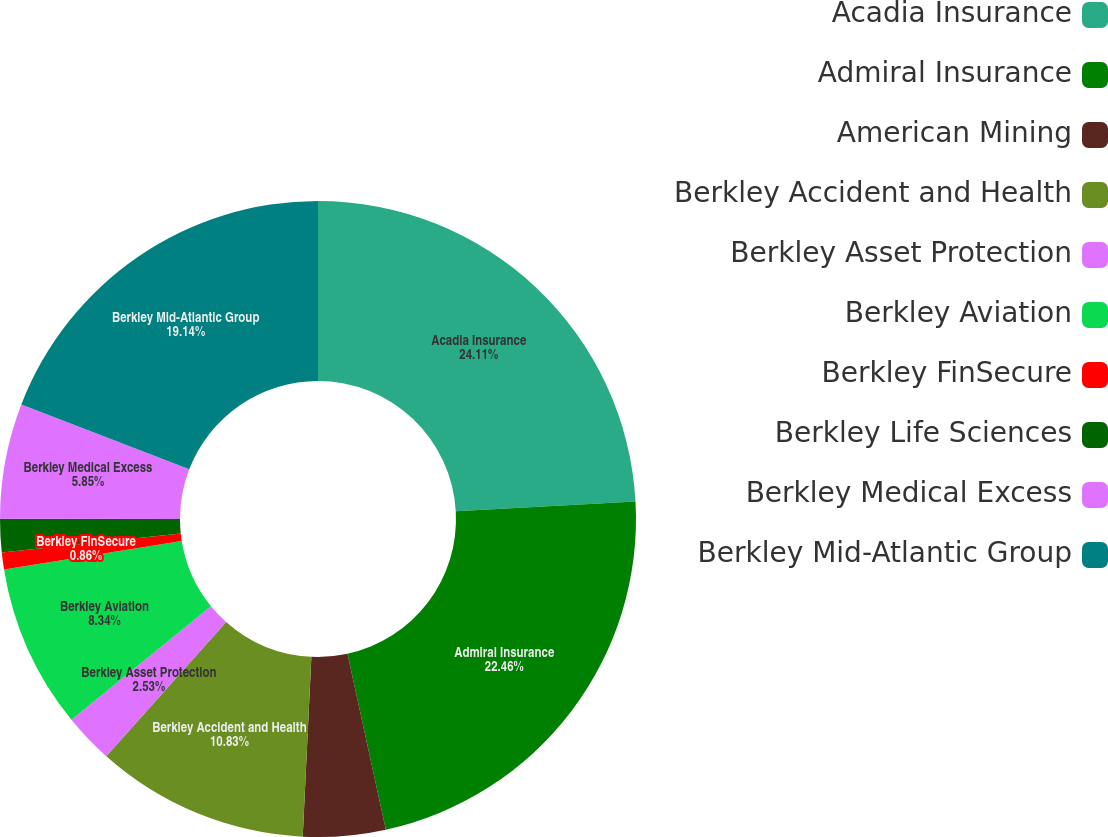<chart> <loc_0><loc_0><loc_500><loc_500><pie_chart><fcel>Acadia Insurance<fcel>Admiral Insurance<fcel>American Mining<fcel>Berkley Accident and Health<fcel>Berkley Asset Protection<fcel>Berkley Aviation<fcel>Berkley FinSecure<fcel>Berkley Life Sciences<fcel>Berkley Medical Excess<fcel>Berkley Mid-Atlantic Group<nl><fcel>24.12%<fcel>22.46%<fcel>4.19%<fcel>10.83%<fcel>2.53%<fcel>8.34%<fcel>0.86%<fcel>1.69%<fcel>5.85%<fcel>19.14%<nl></chart> 